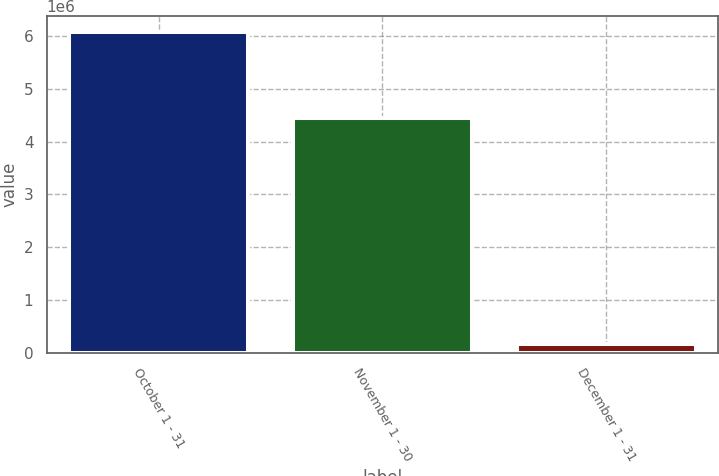Convert chart. <chart><loc_0><loc_0><loc_500><loc_500><bar_chart><fcel>October 1 - 31<fcel>November 1 - 30<fcel>December 1 - 31<nl><fcel>6.07877e+06<fcel>4.44362e+06<fcel>168800<nl></chart> 